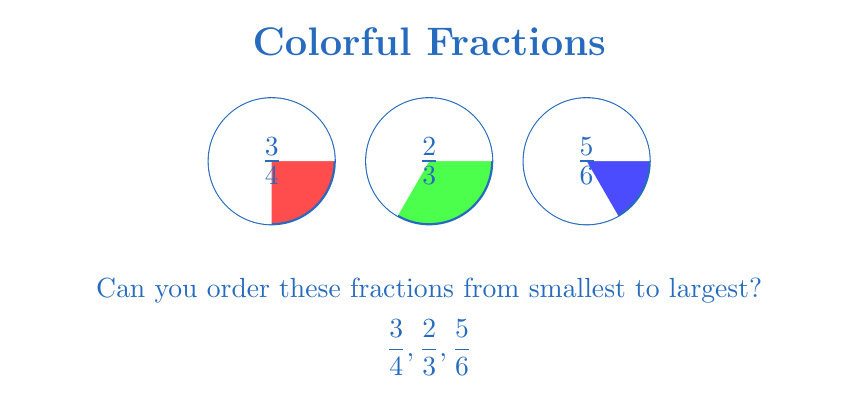Could you help me with this problem? Let's solve this step-by-step:

1) To compare fractions with different denominators, we need to find a common denominator. The least common multiple (LCM) of 4, 3, and 6 is 12.

2) Let's convert each fraction to an equivalent fraction with denominator 12:

   $\frac{3}{4} = \frac{3 \times 3}{4 \times 3} = \frac{9}{12}$
   
   $\frac{2}{3} = \frac{2 \times 4}{3 \times 4} = \frac{8}{12}$
   
   $\frac{5}{6} = \frac{5 \times 2}{6 \times 2} = \frac{10}{12}$

3) Now we can easily compare these fractions:

   $\frac{8}{12} < \frac{9}{12} < \frac{10}{12}$

4) Converting back to our original fractions, we get:

   $\frac{2}{3} < \frac{3}{4} < \frac{5}{6}$

Therefore, the order from smallest to largest is: $\frac{2}{3}, \frac{3}{4}, \frac{5}{6}$.
Answer: $\frac{2}{3}, \frac{3}{4}, \frac{5}{6}$ 